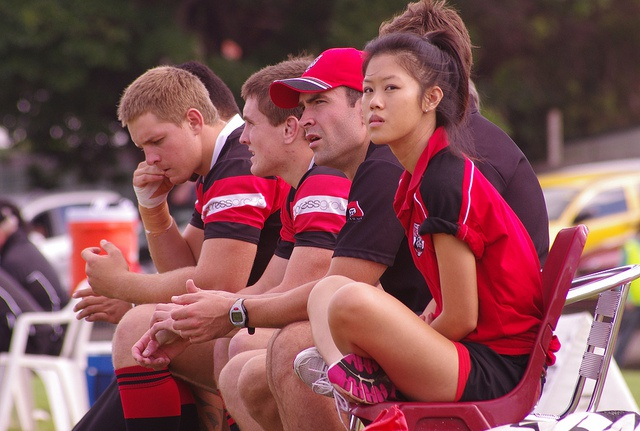Describe the objects in this image and their specific colors. I can see people in black, brown, and lightpink tones, people in black, brown, maroon, and lightpink tones, people in black, brown, lightpink, and maroon tones, people in black, brown, lightpink, and maroon tones, and people in black, purple, maroon, and brown tones in this image. 